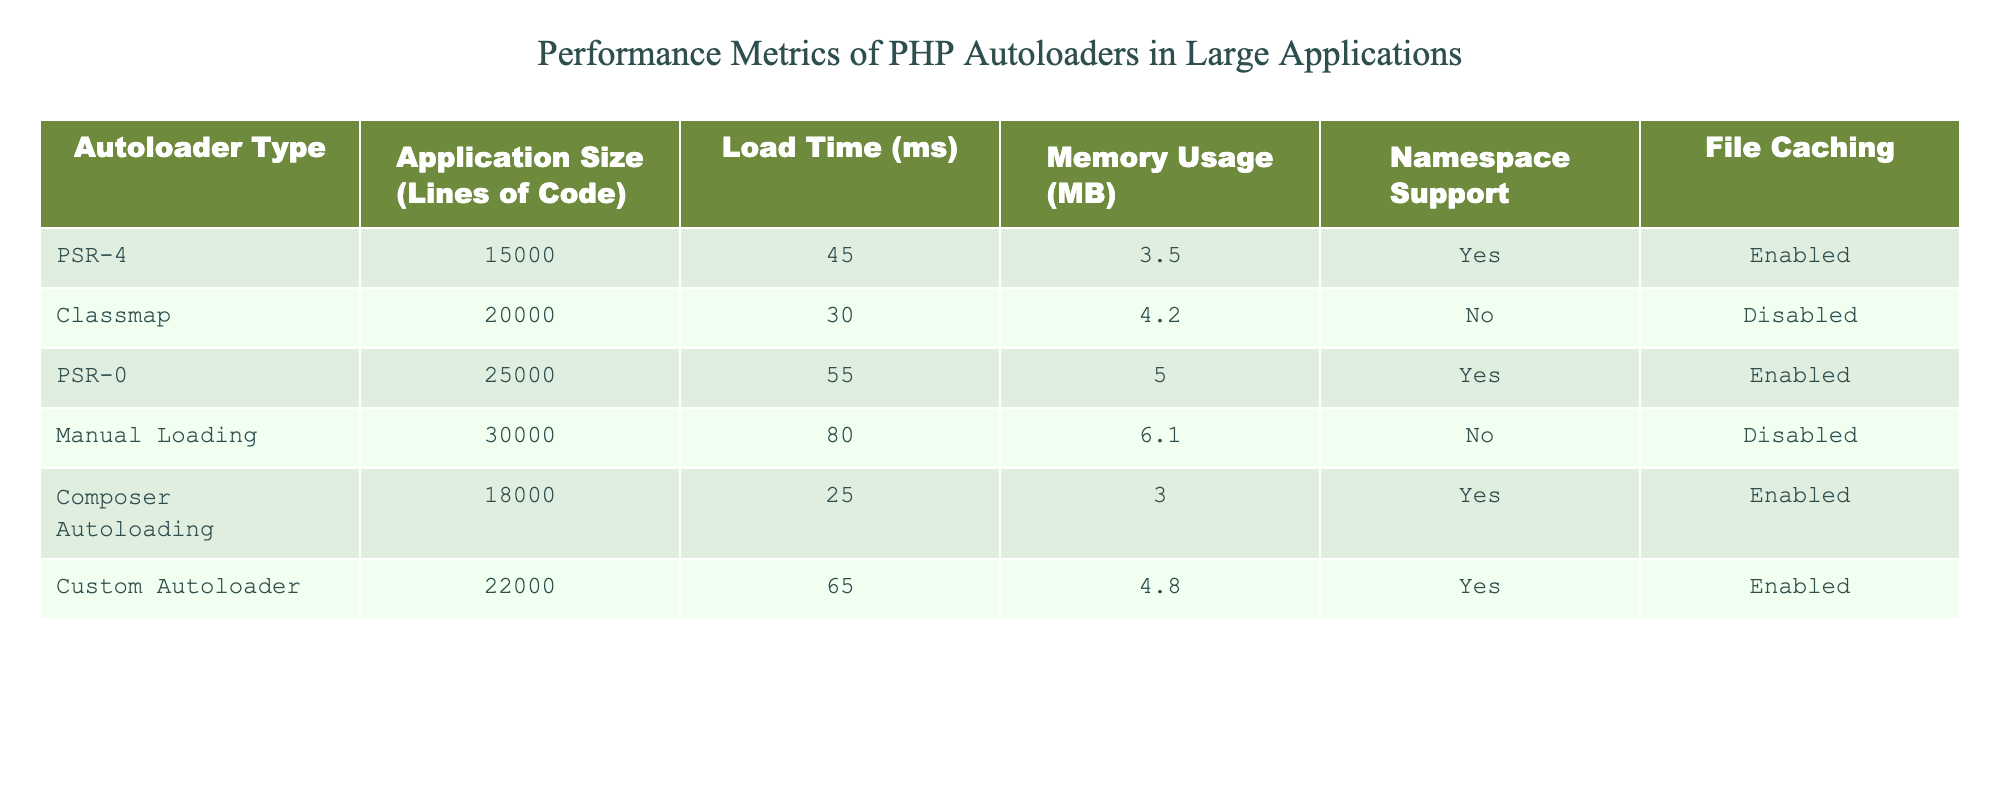What is the load time of the Composer Autoloading? According to the table, the load time for Composer Autoloading is listed as 25 ms. Therefore, we find the specific value corresponding to that autoloader type in the Load Time column.
Answer: 25 ms Which autoloader type has the highest memory usage? By examining the Memory Usage column, we observe that the Manual Loading autoloader has the highest value, which is 6.1 MB. So, we compare the values across all autoloader types to identify the maximum.
Answer: Manual Loading Is there namespace support for the Classmap autoloader? Checking the Namespace Support column for Classmap, the value is listed as "No." Thus, we simply read the entry corresponding to the Classmap row.
Answer: No What is the average load time of the autoloaders listed in the table? To calculate the average load time, we sum all the load times: 45 + 30 + 55 + 80 + 25 + 65 = 300 ms. Then, we divide this sum by the number of autoloaders, which is 6. Thus, the average load time equals 300/6 = 50 ms.
Answer: 50 ms How many autoloaders support file caching? By checking the File Caching column, we see that three autoloaders have "Enabled" marked, namely: PSR-4, Composer Autoloading, and Custom Autoloader. Hence, we can count these entries to find the total.
Answer: 3 What is the difference in load time between the PSR-0 and Classmap autoloaders? The load time for PSR-0 is 55 ms, and for Classmap, it is 30 ms. To find the difference, we subtract the load time of Classmap from that of PSR-0: 55 - 30 = 25 ms. Thus, we calculate the difference directly from the two entries.
Answer: 25 ms Which autoloader type has the least application size in lines of code? Reviewing the Application Size column, Composer Autoloading has the smallest number of lines of code at 18,000. Therefore, we examine the values to identify the minimum.
Answer: Composer Autoloading Is manual loading the most memory-consuming autoloader? Checking the Memory Usage column, we confirm Manual Loading has 6.1 MB, which is higher than all other reported values. Thus, we validate this by comparing it with the other memory usage entries to ensure it's the maximum.
Answer: Yes What is the relationship between namespace support and memory usage in this data? From the table, memory usage varies between autoloaders regardless of namespace support. For example, PSR-4 (3.5 MB) and PSR-0 (5.0 MB) both support namespaces, but their memory usage is not consistent. Thus, we conclude that while some are interconnected, there is no clear direct relationship as memory usage does not depend solely on namespace support.
Answer: Not necessarily correlated 